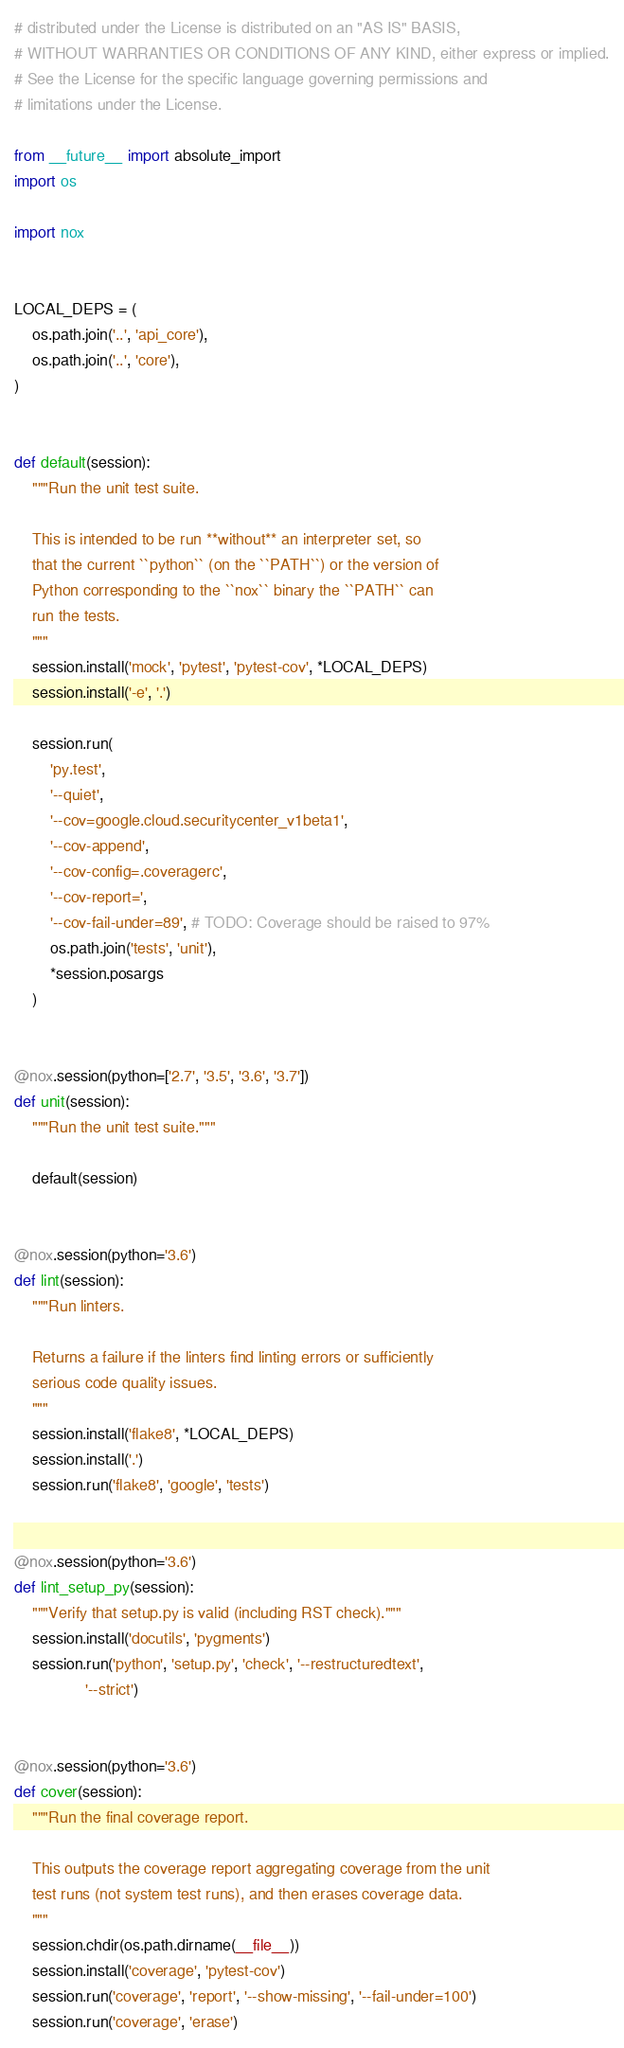<code> <loc_0><loc_0><loc_500><loc_500><_Python_># distributed under the License is distributed on an "AS IS" BASIS,
# WITHOUT WARRANTIES OR CONDITIONS OF ANY KIND, either express or implied.
# See the License for the specific language governing permissions and
# limitations under the License.

from __future__ import absolute_import
import os

import nox


LOCAL_DEPS = (
    os.path.join('..', 'api_core'),
    os.path.join('..', 'core'),
)


def default(session):
    """Run the unit test suite.

    This is intended to be run **without** an interpreter set, so
    that the current ``python`` (on the ``PATH``) or the version of
    Python corresponding to the ``nox`` binary the ``PATH`` can
    run the tests.
    """
    session.install('mock', 'pytest', 'pytest-cov', *LOCAL_DEPS)
    session.install('-e', '.')

    session.run(
        'py.test',
        '--quiet',
        '--cov=google.cloud.securitycenter_v1beta1',
        '--cov-append',
        '--cov-config=.coveragerc',
        '--cov-report=',
        '--cov-fail-under=89', # TODO: Coverage should be raised to 97%
        os.path.join('tests', 'unit'),
        *session.posargs
    )


@nox.session(python=['2.7', '3.5', '3.6', '3.7'])
def unit(session):
    """Run the unit test suite."""

    default(session)


@nox.session(python='3.6')
def lint(session):
    """Run linters.

    Returns a failure if the linters find linting errors or sufficiently
    serious code quality issues.
    """
    session.install('flake8', *LOCAL_DEPS)
    session.install('.')
    session.run('flake8', 'google', 'tests')


@nox.session(python='3.6')
def lint_setup_py(session):
    """Verify that setup.py is valid (including RST check)."""
    session.install('docutils', 'pygments')
    session.run('python', 'setup.py', 'check', '--restructuredtext',
                '--strict')


@nox.session(python='3.6')
def cover(session):
    """Run the final coverage report.

    This outputs the coverage report aggregating coverage from the unit
    test runs (not system test runs), and then erases coverage data.
    """
    session.chdir(os.path.dirname(__file__))
    session.install('coverage', 'pytest-cov')
    session.run('coverage', 'report', '--show-missing', '--fail-under=100')
    session.run('coverage', 'erase')

</code> 